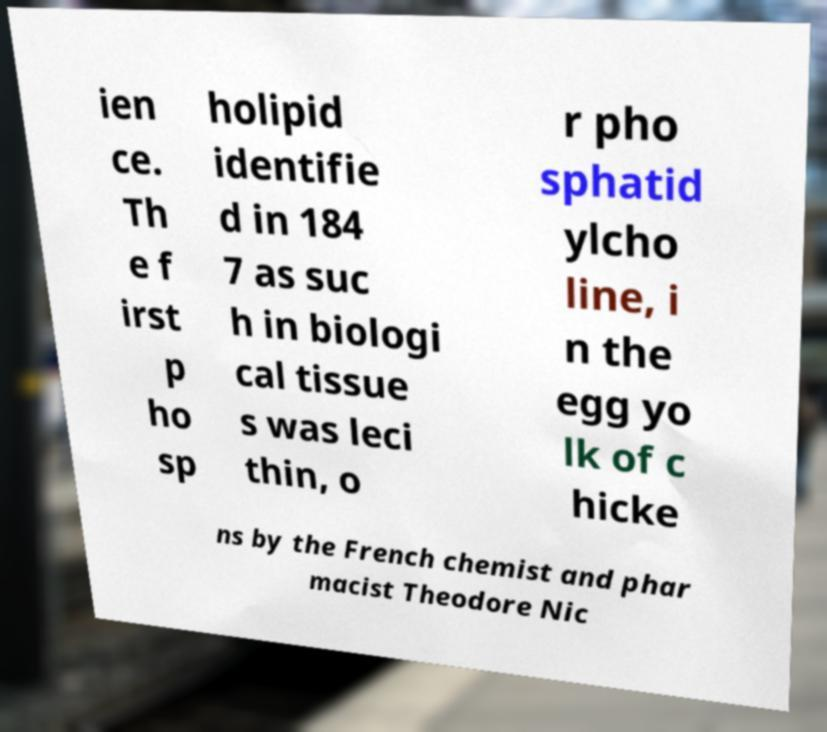Could you extract and type out the text from this image? ien ce. Th e f irst p ho sp holipid identifie d in 184 7 as suc h in biologi cal tissue s was leci thin, o r pho sphatid ylcho line, i n the egg yo lk of c hicke ns by the French chemist and phar macist Theodore Nic 